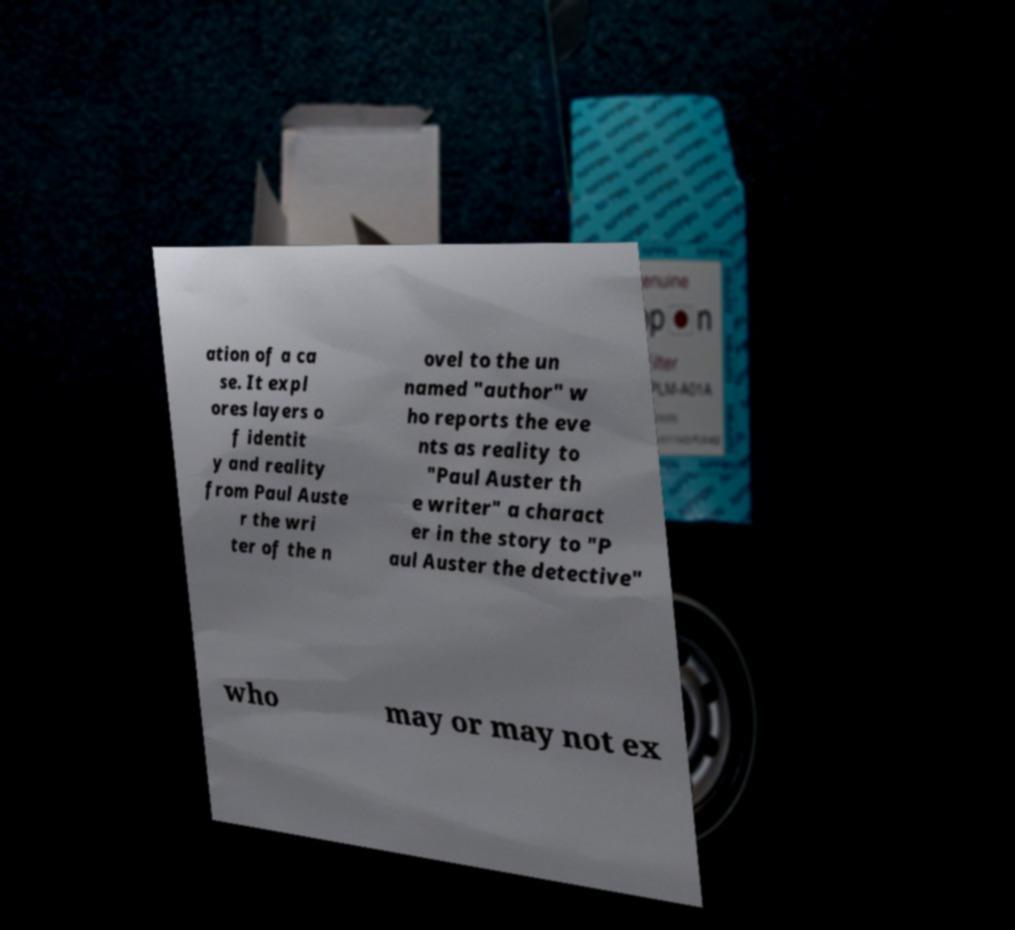Please identify and transcribe the text found in this image. ation of a ca se. It expl ores layers o f identit y and reality from Paul Auste r the wri ter of the n ovel to the un named "author" w ho reports the eve nts as reality to "Paul Auster th e writer" a charact er in the story to "P aul Auster the detective" who may or may not ex 